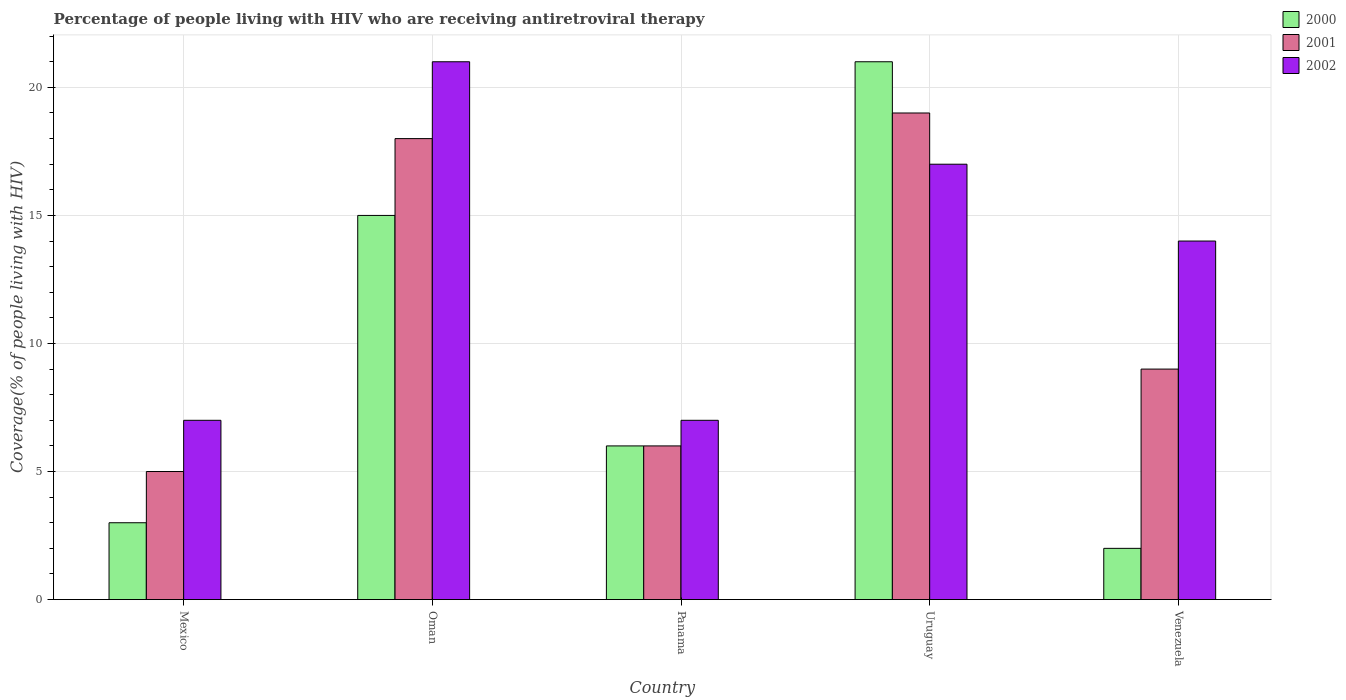How many different coloured bars are there?
Your answer should be very brief. 3. How many bars are there on the 5th tick from the right?
Your answer should be compact. 3. What is the label of the 2nd group of bars from the left?
Give a very brief answer. Oman. In how many cases, is the number of bars for a given country not equal to the number of legend labels?
Your answer should be compact. 0. What is the percentage of the HIV infected people who are receiving antiretroviral therapy in 2000 in Oman?
Your response must be concise. 15. In which country was the percentage of the HIV infected people who are receiving antiretroviral therapy in 2002 maximum?
Give a very brief answer. Oman. In which country was the percentage of the HIV infected people who are receiving antiretroviral therapy in 2000 minimum?
Offer a terse response. Venezuela. What is the total percentage of the HIV infected people who are receiving antiretroviral therapy in 2001 in the graph?
Keep it short and to the point. 57. What is the difference between the percentage of the HIV infected people who are receiving antiretroviral therapy in 2001 in Mexico and that in Panama?
Provide a succinct answer. -1. What is the difference between the percentage of the HIV infected people who are receiving antiretroviral therapy in 2001 in Venezuela and the percentage of the HIV infected people who are receiving antiretroviral therapy in 2000 in Mexico?
Your answer should be very brief. 6. What is the average percentage of the HIV infected people who are receiving antiretroviral therapy in 2000 per country?
Offer a terse response. 9.4. What is the difference between the percentage of the HIV infected people who are receiving antiretroviral therapy of/in 2001 and percentage of the HIV infected people who are receiving antiretroviral therapy of/in 2002 in Panama?
Offer a very short reply. -1. In how many countries, is the percentage of the HIV infected people who are receiving antiretroviral therapy in 2002 greater than 12 %?
Provide a succinct answer. 3. What is the ratio of the percentage of the HIV infected people who are receiving antiretroviral therapy in 2001 in Mexico to that in Panama?
Give a very brief answer. 0.83. Is the percentage of the HIV infected people who are receiving antiretroviral therapy in 2001 in Oman less than that in Panama?
Offer a terse response. No. Is the difference between the percentage of the HIV infected people who are receiving antiretroviral therapy in 2001 in Panama and Venezuela greater than the difference between the percentage of the HIV infected people who are receiving antiretroviral therapy in 2002 in Panama and Venezuela?
Give a very brief answer. Yes. What is the difference between the highest and the second highest percentage of the HIV infected people who are receiving antiretroviral therapy in 2001?
Provide a succinct answer. -9. What is the difference between the highest and the lowest percentage of the HIV infected people who are receiving antiretroviral therapy in 2001?
Your answer should be very brief. 14. In how many countries, is the percentage of the HIV infected people who are receiving antiretroviral therapy in 2000 greater than the average percentage of the HIV infected people who are receiving antiretroviral therapy in 2000 taken over all countries?
Make the answer very short. 2. What does the 2nd bar from the right in Uruguay represents?
Offer a terse response. 2001. Are the values on the major ticks of Y-axis written in scientific E-notation?
Give a very brief answer. No. Does the graph contain grids?
Ensure brevity in your answer.  Yes. How many legend labels are there?
Your response must be concise. 3. What is the title of the graph?
Make the answer very short. Percentage of people living with HIV who are receiving antiretroviral therapy. What is the label or title of the Y-axis?
Your answer should be compact. Coverage(% of people living with HIV). What is the Coverage(% of people living with HIV) of 2000 in Mexico?
Your answer should be compact. 3. What is the Coverage(% of people living with HIV) of 2001 in Mexico?
Provide a succinct answer. 5. What is the Coverage(% of people living with HIV) in 2000 in Oman?
Give a very brief answer. 15. What is the Coverage(% of people living with HIV) of 2001 in Oman?
Your answer should be very brief. 18. What is the Coverage(% of people living with HIV) of 2002 in Oman?
Make the answer very short. 21. What is the Coverage(% of people living with HIV) in 2000 in Uruguay?
Your answer should be compact. 21. What is the Coverage(% of people living with HIV) in 2001 in Uruguay?
Offer a terse response. 19. What is the Coverage(% of people living with HIV) of 2002 in Uruguay?
Provide a short and direct response. 17. What is the Coverage(% of people living with HIV) of 2000 in Venezuela?
Give a very brief answer. 2. What is the Coverage(% of people living with HIV) of 2002 in Venezuela?
Provide a short and direct response. 14. Across all countries, what is the maximum Coverage(% of people living with HIV) of 2001?
Ensure brevity in your answer.  19. Across all countries, what is the maximum Coverage(% of people living with HIV) in 2002?
Provide a short and direct response. 21. Across all countries, what is the minimum Coverage(% of people living with HIV) of 2000?
Offer a very short reply. 2. Across all countries, what is the minimum Coverage(% of people living with HIV) of 2001?
Make the answer very short. 5. Across all countries, what is the minimum Coverage(% of people living with HIV) in 2002?
Make the answer very short. 7. What is the total Coverage(% of people living with HIV) of 2001 in the graph?
Offer a terse response. 57. What is the total Coverage(% of people living with HIV) in 2002 in the graph?
Keep it short and to the point. 66. What is the difference between the Coverage(% of people living with HIV) of 2000 in Mexico and that in Oman?
Offer a terse response. -12. What is the difference between the Coverage(% of people living with HIV) in 2002 in Mexico and that in Oman?
Keep it short and to the point. -14. What is the difference between the Coverage(% of people living with HIV) in 2001 in Mexico and that in Panama?
Provide a short and direct response. -1. What is the difference between the Coverage(% of people living with HIV) of 2002 in Mexico and that in Panama?
Offer a terse response. 0. What is the difference between the Coverage(% of people living with HIV) of 2000 in Mexico and that in Uruguay?
Ensure brevity in your answer.  -18. What is the difference between the Coverage(% of people living with HIV) of 2000 in Mexico and that in Venezuela?
Ensure brevity in your answer.  1. What is the difference between the Coverage(% of people living with HIV) of 2000 in Oman and that in Panama?
Keep it short and to the point. 9. What is the difference between the Coverage(% of people living with HIV) in 2002 in Oman and that in Uruguay?
Ensure brevity in your answer.  4. What is the difference between the Coverage(% of people living with HIV) in 2002 in Oman and that in Venezuela?
Your answer should be very brief. 7. What is the difference between the Coverage(% of people living with HIV) in 2000 in Panama and that in Uruguay?
Provide a short and direct response. -15. What is the difference between the Coverage(% of people living with HIV) of 2001 in Panama and that in Uruguay?
Give a very brief answer. -13. What is the difference between the Coverage(% of people living with HIV) of 2002 in Panama and that in Uruguay?
Offer a very short reply. -10. What is the difference between the Coverage(% of people living with HIV) in 2000 in Panama and that in Venezuela?
Offer a terse response. 4. What is the difference between the Coverage(% of people living with HIV) in 2002 in Panama and that in Venezuela?
Offer a terse response. -7. What is the difference between the Coverage(% of people living with HIV) in 2000 in Uruguay and that in Venezuela?
Keep it short and to the point. 19. What is the difference between the Coverage(% of people living with HIV) in 2000 in Mexico and the Coverage(% of people living with HIV) in 2001 in Oman?
Make the answer very short. -15. What is the difference between the Coverage(% of people living with HIV) of 2001 in Mexico and the Coverage(% of people living with HIV) of 2002 in Oman?
Ensure brevity in your answer.  -16. What is the difference between the Coverage(% of people living with HIV) of 2000 in Mexico and the Coverage(% of people living with HIV) of 2001 in Panama?
Provide a succinct answer. -3. What is the difference between the Coverage(% of people living with HIV) in 2000 in Mexico and the Coverage(% of people living with HIV) in 2002 in Panama?
Offer a very short reply. -4. What is the difference between the Coverage(% of people living with HIV) of 2000 in Mexico and the Coverage(% of people living with HIV) of 2002 in Uruguay?
Your answer should be very brief. -14. What is the difference between the Coverage(% of people living with HIV) in 2001 in Mexico and the Coverage(% of people living with HIV) in 2002 in Uruguay?
Make the answer very short. -12. What is the difference between the Coverage(% of people living with HIV) in 2000 in Mexico and the Coverage(% of people living with HIV) in 2002 in Venezuela?
Offer a terse response. -11. What is the difference between the Coverage(% of people living with HIV) of 2001 in Mexico and the Coverage(% of people living with HIV) of 2002 in Venezuela?
Your answer should be very brief. -9. What is the difference between the Coverage(% of people living with HIV) in 2000 in Oman and the Coverage(% of people living with HIV) in 2002 in Panama?
Keep it short and to the point. 8. What is the difference between the Coverage(% of people living with HIV) of 2000 in Oman and the Coverage(% of people living with HIV) of 2002 in Venezuela?
Your answer should be compact. 1. What is the difference between the Coverage(% of people living with HIV) in 2000 in Panama and the Coverage(% of people living with HIV) in 2002 in Uruguay?
Give a very brief answer. -11. What is the difference between the Coverage(% of people living with HIV) of 2000 in Panama and the Coverage(% of people living with HIV) of 2001 in Venezuela?
Give a very brief answer. -3. What is the difference between the Coverage(% of people living with HIV) of 2001 in Panama and the Coverage(% of people living with HIV) of 2002 in Venezuela?
Provide a succinct answer. -8. What is the difference between the Coverage(% of people living with HIV) of 2001 in Uruguay and the Coverage(% of people living with HIV) of 2002 in Venezuela?
Provide a short and direct response. 5. What is the average Coverage(% of people living with HIV) in 2000 per country?
Keep it short and to the point. 9.4. What is the average Coverage(% of people living with HIV) of 2001 per country?
Keep it short and to the point. 11.4. What is the difference between the Coverage(% of people living with HIV) of 2000 and Coverage(% of people living with HIV) of 2002 in Mexico?
Give a very brief answer. -4. What is the difference between the Coverage(% of people living with HIV) of 2001 and Coverage(% of people living with HIV) of 2002 in Mexico?
Provide a short and direct response. -2. What is the difference between the Coverage(% of people living with HIV) in 2001 and Coverage(% of people living with HIV) in 2002 in Oman?
Keep it short and to the point. -3. What is the difference between the Coverage(% of people living with HIV) of 2000 and Coverage(% of people living with HIV) of 2001 in Panama?
Make the answer very short. 0. What is the difference between the Coverage(% of people living with HIV) of 2000 and Coverage(% of people living with HIV) of 2002 in Panama?
Keep it short and to the point. -1. What is the difference between the Coverage(% of people living with HIV) in 2000 and Coverage(% of people living with HIV) in 2002 in Uruguay?
Your response must be concise. 4. What is the difference between the Coverage(% of people living with HIV) in 2001 and Coverage(% of people living with HIV) in 2002 in Uruguay?
Provide a succinct answer. 2. What is the difference between the Coverage(% of people living with HIV) of 2000 and Coverage(% of people living with HIV) of 2001 in Venezuela?
Offer a very short reply. -7. What is the difference between the Coverage(% of people living with HIV) in 2001 and Coverage(% of people living with HIV) in 2002 in Venezuela?
Give a very brief answer. -5. What is the ratio of the Coverage(% of people living with HIV) of 2000 in Mexico to that in Oman?
Offer a very short reply. 0.2. What is the ratio of the Coverage(% of people living with HIV) in 2001 in Mexico to that in Oman?
Your answer should be very brief. 0.28. What is the ratio of the Coverage(% of people living with HIV) of 2001 in Mexico to that in Panama?
Make the answer very short. 0.83. What is the ratio of the Coverage(% of people living with HIV) in 2002 in Mexico to that in Panama?
Keep it short and to the point. 1. What is the ratio of the Coverage(% of people living with HIV) in 2000 in Mexico to that in Uruguay?
Your response must be concise. 0.14. What is the ratio of the Coverage(% of people living with HIV) in 2001 in Mexico to that in Uruguay?
Ensure brevity in your answer.  0.26. What is the ratio of the Coverage(% of people living with HIV) in 2002 in Mexico to that in Uruguay?
Your response must be concise. 0.41. What is the ratio of the Coverage(% of people living with HIV) of 2000 in Mexico to that in Venezuela?
Keep it short and to the point. 1.5. What is the ratio of the Coverage(% of people living with HIV) of 2001 in Mexico to that in Venezuela?
Offer a terse response. 0.56. What is the ratio of the Coverage(% of people living with HIV) of 2000 in Oman to that in Panama?
Provide a succinct answer. 2.5. What is the ratio of the Coverage(% of people living with HIV) in 2002 in Oman to that in Panama?
Keep it short and to the point. 3. What is the ratio of the Coverage(% of people living with HIV) in 2000 in Oman to that in Uruguay?
Your response must be concise. 0.71. What is the ratio of the Coverage(% of people living with HIV) in 2001 in Oman to that in Uruguay?
Your answer should be compact. 0.95. What is the ratio of the Coverage(% of people living with HIV) in 2002 in Oman to that in Uruguay?
Keep it short and to the point. 1.24. What is the ratio of the Coverage(% of people living with HIV) of 2000 in Oman to that in Venezuela?
Your answer should be very brief. 7.5. What is the ratio of the Coverage(% of people living with HIV) of 2000 in Panama to that in Uruguay?
Keep it short and to the point. 0.29. What is the ratio of the Coverage(% of people living with HIV) in 2001 in Panama to that in Uruguay?
Give a very brief answer. 0.32. What is the ratio of the Coverage(% of people living with HIV) of 2002 in Panama to that in Uruguay?
Give a very brief answer. 0.41. What is the ratio of the Coverage(% of people living with HIV) of 2001 in Panama to that in Venezuela?
Make the answer very short. 0.67. What is the ratio of the Coverage(% of people living with HIV) of 2001 in Uruguay to that in Venezuela?
Give a very brief answer. 2.11. What is the ratio of the Coverage(% of people living with HIV) of 2002 in Uruguay to that in Venezuela?
Your response must be concise. 1.21. What is the difference between the highest and the second highest Coverage(% of people living with HIV) of 2000?
Ensure brevity in your answer.  6. What is the difference between the highest and the second highest Coverage(% of people living with HIV) in 2001?
Offer a very short reply. 1. What is the difference between the highest and the second highest Coverage(% of people living with HIV) in 2002?
Offer a terse response. 4. What is the difference between the highest and the lowest Coverage(% of people living with HIV) in 2000?
Ensure brevity in your answer.  19. What is the difference between the highest and the lowest Coverage(% of people living with HIV) in 2001?
Give a very brief answer. 14. 